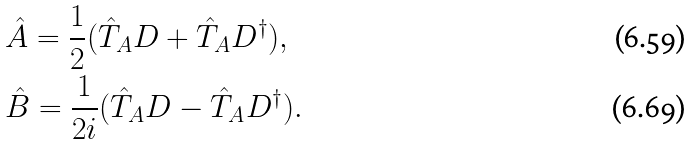Convert formula to latex. <formula><loc_0><loc_0><loc_500><loc_500>& \hat { A } = \frac { 1 } { 2 } ( \hat { T } _ { A } D + \hat { T } _ { A } D ^ { \dagger } ) , \\ & \hat { B } = \frac { 1 } { 2 i } ( \hat { T } _ { A } D - \hat { T } _ { A } D ^ { \dagger } ) .</formula> 